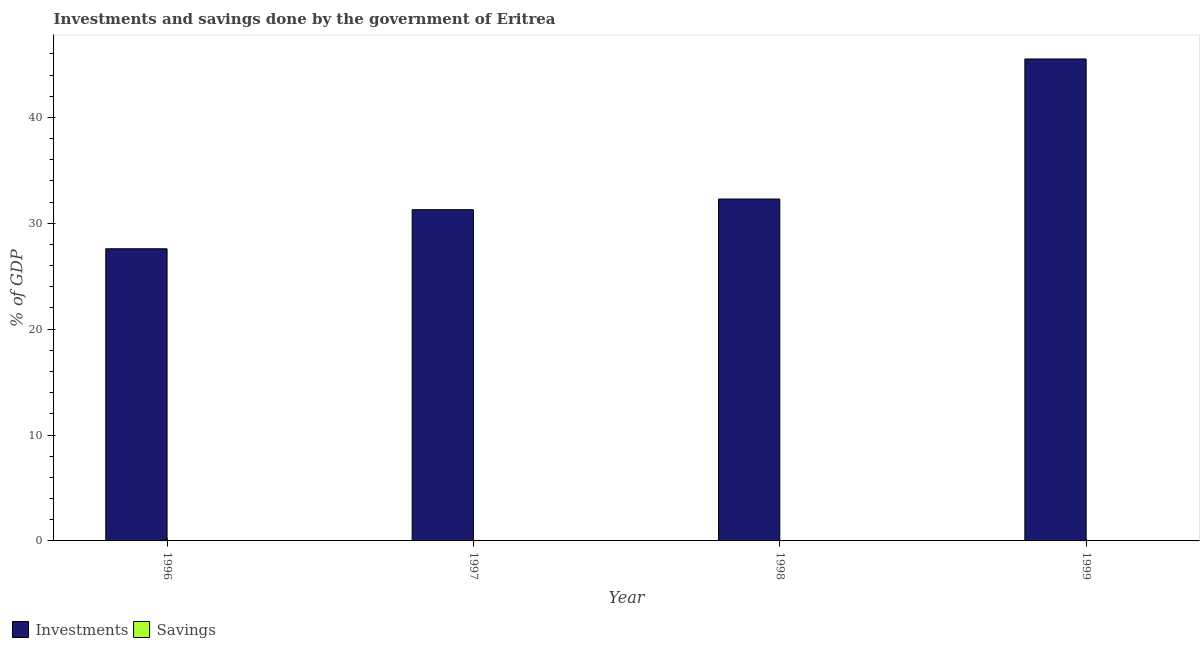How many different coloured bars are there?
Your answer should be compact. 1. Are the number of bars per tick equal to the number of legend labels?
Ensure brevity in your answer.  No. How many bars are there on the 2nd tick from the left?
Provide a short and direct response. 1. What is the label of the 4th group of bars from the left?
Keep it short and to the point. 1999. Across all years, what is the maximum investments of government?
Your response must be concise. 45.51. What is the total investments of government in the graph?
Offer a terse response. 136.67. What is the difference between the investments of government in 1996 and that in 1997?
Your response must be concise. -3.69. What is the average investments of government per year?
Keep it short and to the point. 34.17. In the year 1996, what is the difference between the investments of government and savings of government?
Ensure brevity in your answer.  0. What is the ratio of the investments of government in 1998 to that in 1999?
Provide a succinct answer. 0.71. Is the investments of government in 1997 less than that in 1998?
Offer a very short reply. Yes. Is the difference between the investments of government in 1996 and 1998 greater than the difference between the savings of government in 1996 and 1998?
Provide a short and direct response. No. What is the difference between the highest and the second highest investments of government?
Offer a very short reply. 13.23. What is the difference between the highest and the lowest investments of government?
Offer a very short reply. 17.92. How many bars are there?
Provide a succinct answer. 4. Are all the bars in the graph horizontal?
Provide a short and direct response. No. How many years are there in the graph?
Ensure brevity in your answer.  4. What is the difference between two consecutive major ticks on the Y-axis?
Offer a terse response. 10. Are the values on the major ticks of Y-axis written in scientific E-notation?
Give a very brief answer. No. Does the graph contain grids?
Your response must be concise. No. How are the legend labels stacked?
Ensure brevity in your answer.  Horizontal. What is the title of the graph?
Your answer should be very brief. Investments and savings done by the government of Eritrea. Does "International Tourists" appear as one of the legend labels in the graph?
Offer a very short reply. No. What is the label or title of the X-axis?
Your answer should be very brief. Year. What is the label or title of the Y-axis?
Offer a terse response. % of GDP. What is the % of GDP in Investments in 1996?
Offer a terse response. 27.59. What is the % of GDP of Savings in 1996?
Your answer should be compact. 0. What is the % of GDP of Investments in 1997?
Give a very brief answer. 31.28. What is the % of GDP in Investments in 1998?
Your answer should be compact. 32.29. What is the % of GDP in Investments in 1999?
Your response must be concise. 45.51. Across all years, what is the maximum % of GDP in Investments?
Give a very brief answer. 45.51. Across all years, what is the minimum % of GDP of Investments?
Offer a very short reply. 27.59. What is the total % of GDP in Investments in the graph?
Make the answer very short. 136.67. What is the difference between the % of GDP in Investments in 1996 and that in 1997?
Provide a short and direct response. -3.69. What is the difference between the % of GDP in Investments in 1996 and that in 1998?
Your answer should be very brief. -4.7. What is the difference between the % of GDP in Investments in 1996 and that in 1999?
Your answer should be compact. -17.92. What is the difference between the % of GDP in Investments in 1997 and that in 1998?
Your answer should be very brief. -1.01. What is the difference between the % of GDP in Investments in 1997 and that in 1999?
Offer a terse response. -14.23. What is the difference between the % of GDP in Investments in 1998 and that in 1999?
Offer a terse response. -13.23. What is the average % of GDP of Investments per year?
Ensure brevity in your answer.  34.17. What is the average % of GDP of Savings per year?
Your response must be concise. 0. What is the ratio of the % of GDP in Investments in 1996 to that in 1997?
Your answer should be very brief. 0.88. What is the ratio of the % of GDP of Investments in 1996 to that in 1998?
Your answer should be very brief. 0.85. What is the ratio of the % of GDP of Investments in 1996 to that in 1999?
Offer a terse response. 0.61. What is the ratio of the % of GDP of Investments in 1997 to that in 1998?
Provide a short and direct response. 0.97. What is the ratio of the % of GDP of Investments in 1997 to that in 1999?
Your answer should be compact. 0.69. What is the ratio of the % of GDP in Investments in 1998 to that in 1999?
Give a very brief answer. 0.71. What is the difference between the highest and the second highest % of GDP of Investments?
Your response must be concise. 13.23. What is the difference between the highest and the lowest % of GDP in Investments?
Your answer should be very brief. 17.92. 